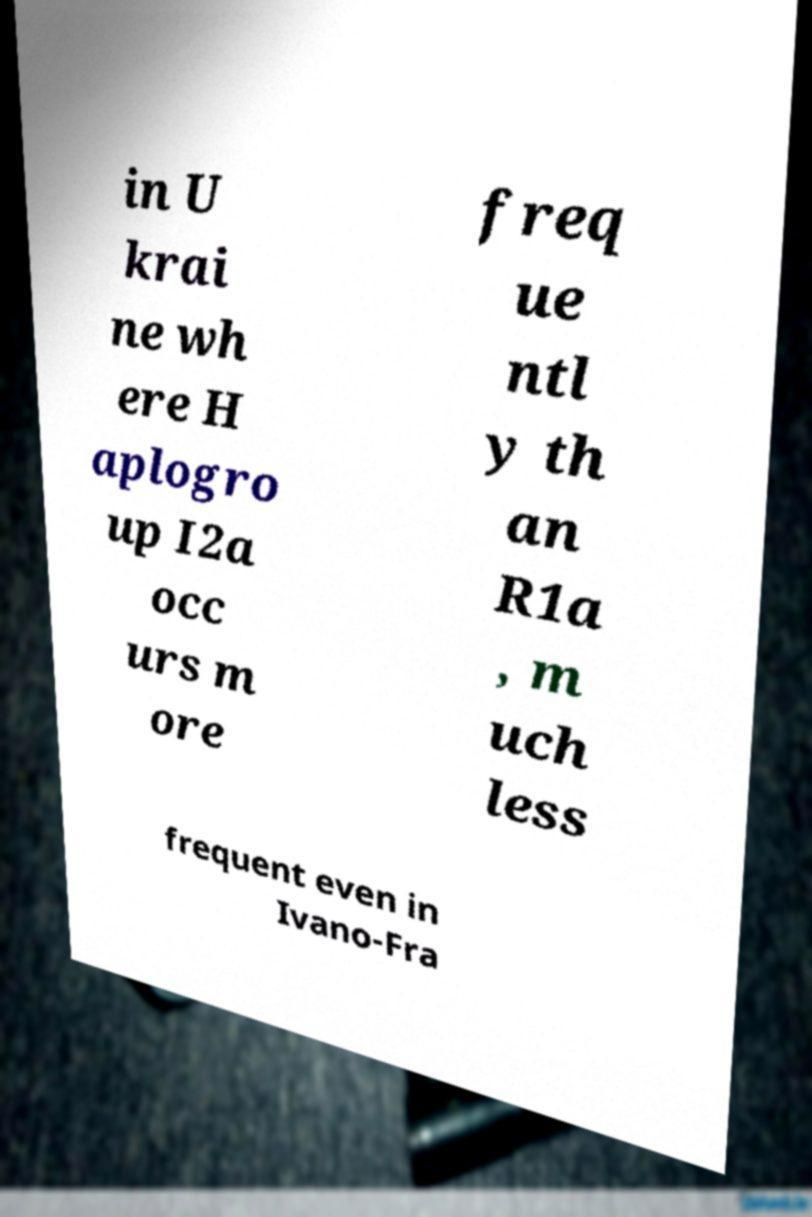For documentation purposes, I need the text within this image transcribed. Could you provide that? in U krai ne wh ere H aplogro up I2a occ urs m ore freq ue ntl y th an R1a , m uch less frequent even in Ivano-Fra 